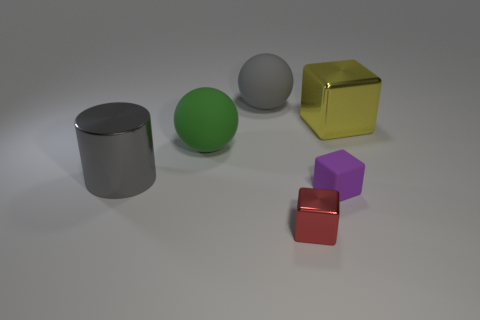There is a rubber thing that is in front of the big yellow metal cube and to the left of the red metallic block; what size is it?
Offer a very short reply. Large. Is the number of large yellow blocks that are to the right of the big yellow metal block less than the number of gray objects that are in front of the large gray matte sphere?
Your answer should be very brief. Yes. Are the gray thing right of the big gray metallic cylinder and the big gray object that is in front of the big gray matte sphere made of the same material?
Your response must be concise. No. There is a big object that is both in front of the big cube and to the right of the gray metallic thing; what is its shape?
Offer a very short reply. Sphere. What is the large object that is to the right of the metal cube that is in front of the large cylinder made of?
Keep it short and to the point. Metal. Is the number of big yellow metallic cubes greater than the number of big gray objects?
Offer a very short reply. No. There is a yellow thing that is the same size as the gray metallic cylinder; what material is it?
Give a very brief answer. Metal. Does the cylinder have the same material as the purple thing?
Offer a terse response. No. How many green cubes are made of the same material as the red thing?
Provide a short and direct response. 0. How many things are either blocks that are to the left of the tiny rubber cube or tiny blocks behind the tiny metal object?
Offer a terse response. 2. 